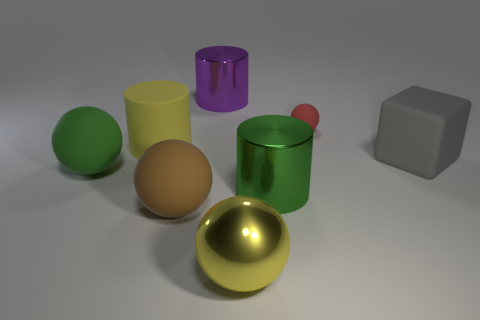What material do the objects in the image look like they are made of? The objects in the image seem to be made of various materials—the yellow and red spheres have a reflective surface suggesting a metallic finish. The green and purple cylinders appear to have a glass or plastic-like material due to their translucency and shine. The brown sphere and beige sphere present a matte finish, hinting at a texture akin to rubber or matte-painted surface, while the gray cube suggests a matte plastic or concrete appearance. 